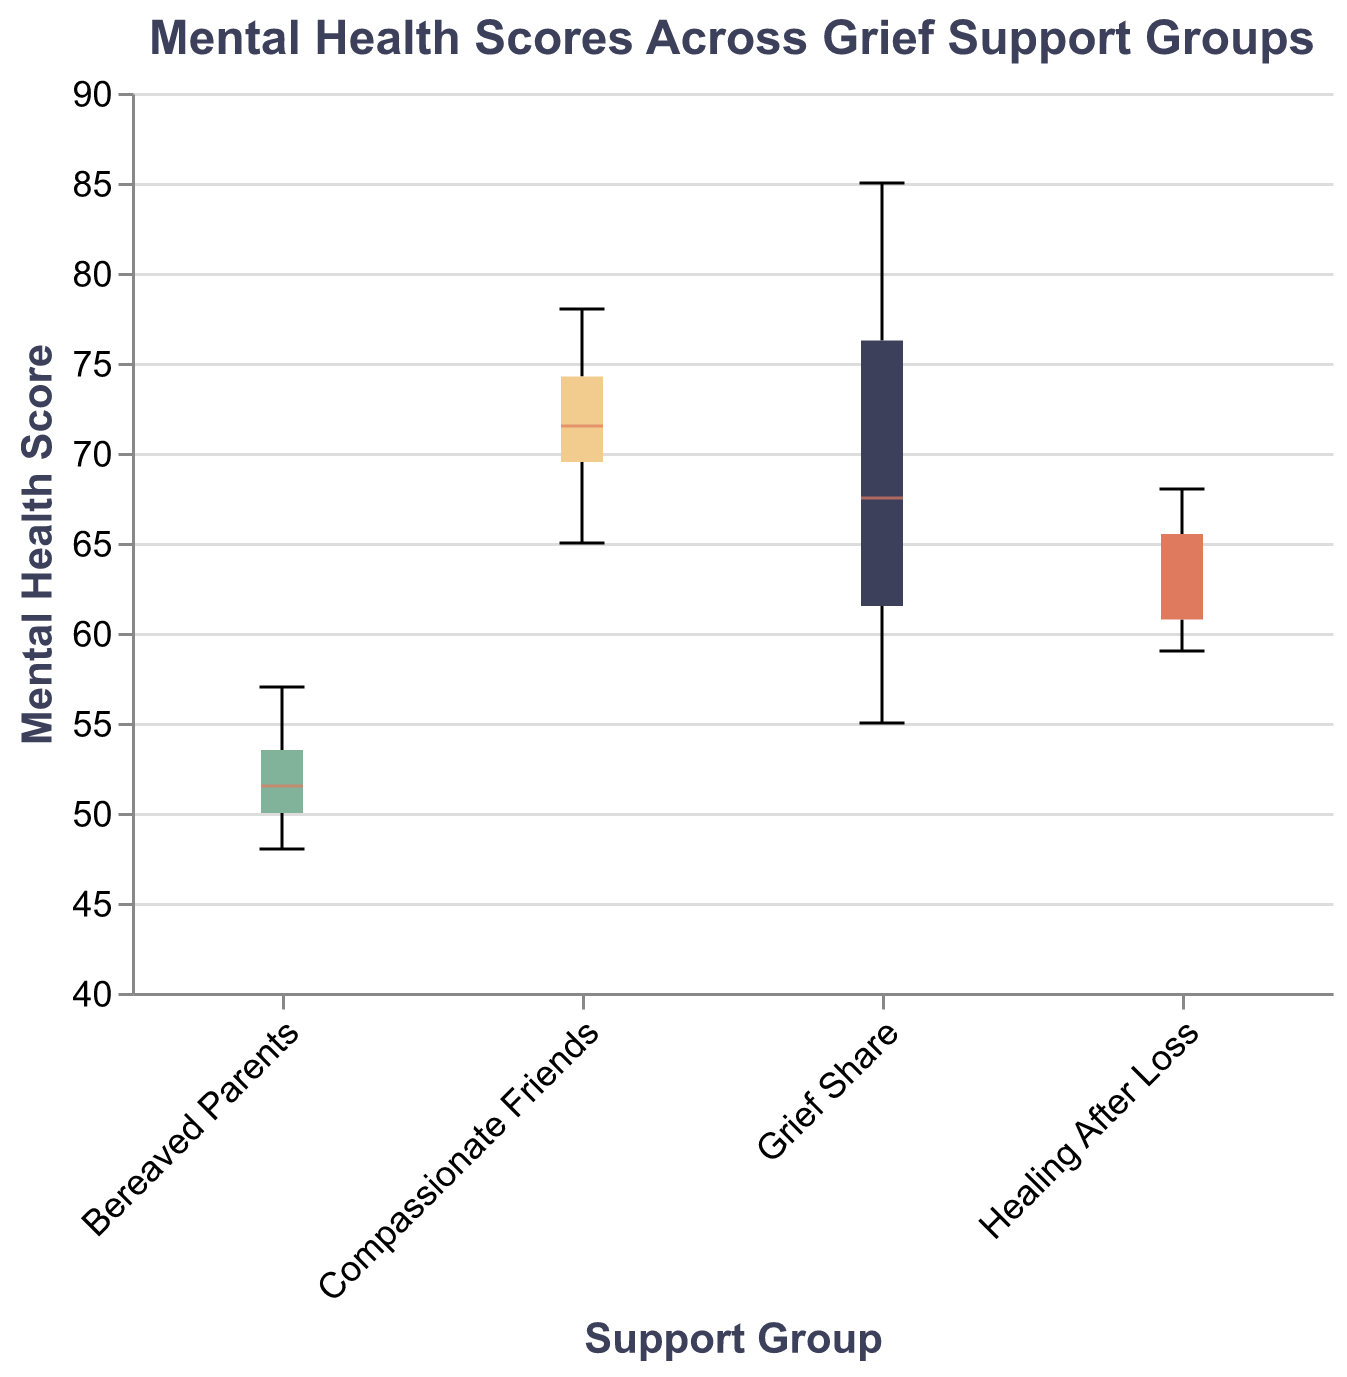What is the title of the plot? The title is prominently displayed at the top of the plot. It reads "Mental Health Scores Across Grief Support Groups".
Answer: Mental Health Scores Across Grief Support Groups Which support group has the highest median score? From the box plots, the median is usually indicated by a line within the box. The group with the highest median is "Grief Share".
Answer: Grief Share What is the color used to represent the "Healing After Loss" group? The color for each support group is indicated in the legend or can be observed from the plot. "Healing After Loss" is represented in a reddish color.
Answer: Reddish What is the range of mental health scores for the "Bereaved Parents" group? The range is indicated by the box plot's whiskers, showing the minimum and maximum values. For "Bereaved Parents," the scores range from 48 to 57.
Answer: 48 to 57 Which support group has the widest range of scores? To find the widest range, compare the length of the whiskers for each group. The longest whiskers span the range, which is the "Grief Share" group.
Answer: Grief Share How does the median score of "Compassionate Friends" compare to the median score of "Healing After Loss"? The median for "Compassionate Friends" and "Healing After Loss" can be compared by looking at their respective median lines. "Compassionate Friends" has a higher median score than "Healing After Loss".
Answer: Higher What is the interquartile range (IQR) for "Healing After Loss"? The IQR is the range between the first quartile (bottom of the box) and the third quartile (top of the box). For "Healing After Loss," it ranges from approximately 60 to 65, making the IQR 5.
Answer: 5 Which group appears to have the smallest variability in scores? Variability in scores can be observed by the length of the box and whiskers. The "Bereaved Parents" group has the smallest box and whiskers, indicating the least variability.
Answer: Bereaved Parents What is the maximum score recorded in the "Compassionate Friends" group? The maximum value is the top whisker in the box plot. For "Compassionate Friends," the maximum score is 78.
Answer: 78 